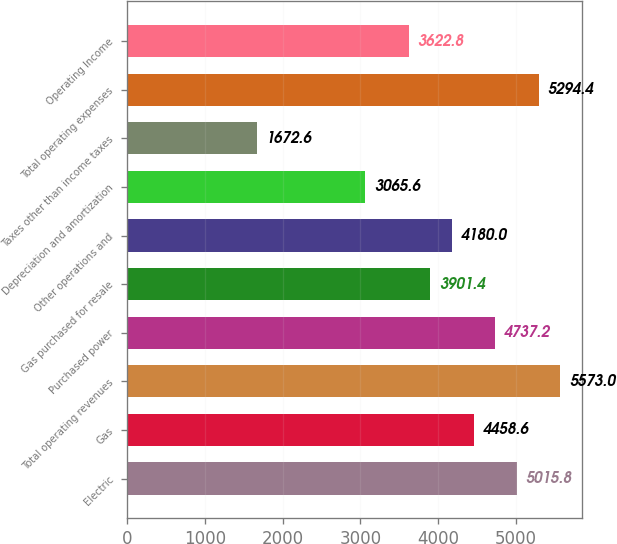Convert chart. <chart><loc_0><loc_0><loc_500><loc_500><bar_chart><fcel>Electric<fcel>Gas<fcel>Total operating revenues<fcel>Purchased power<fcel>Gas purchased for resale<fcel>Other operations and<fcel>Depreciation and amortization<fcel>Taxes other than income taxes<fcel>Total operating expenses<fcel>Operating Income<nl><fcel>5015.8<fcel>4458.6<fcel>5573<fcel>4737.2<fcel>3901.4<fcel>4180<fcel>3065.6<fcel>1672.6<fcel>5294.4<fcel>3622.8<nl></chart> 